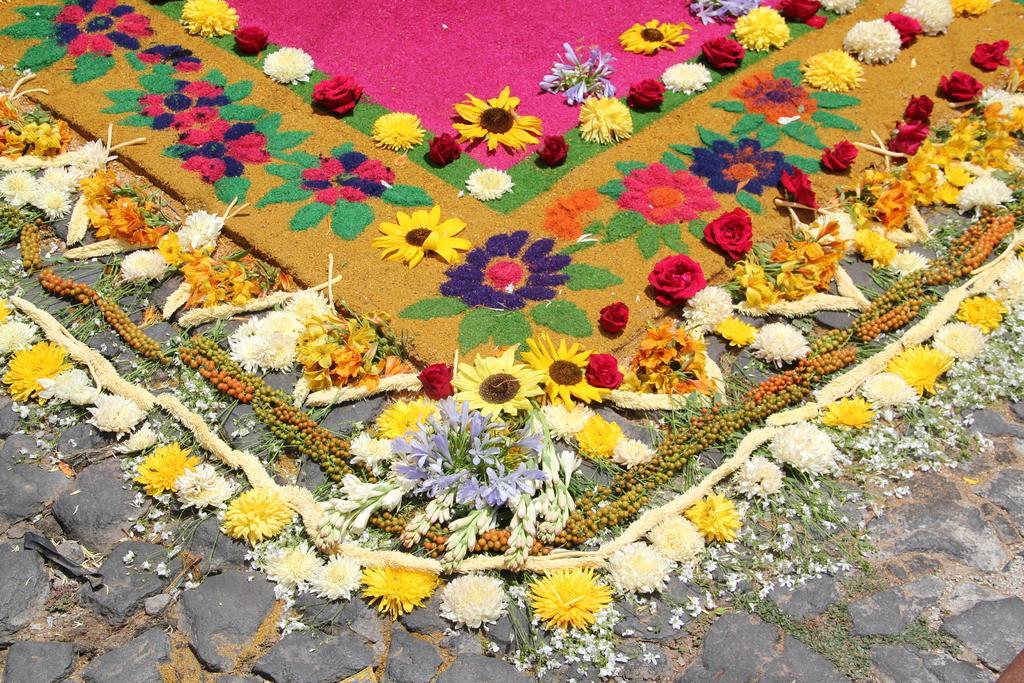In one or two sentences, can you explain what this image depicts? In the picture we can see a rock path on it, we can see a mat which is decorated with flowers on it and around the mat also we can see with flowers. 